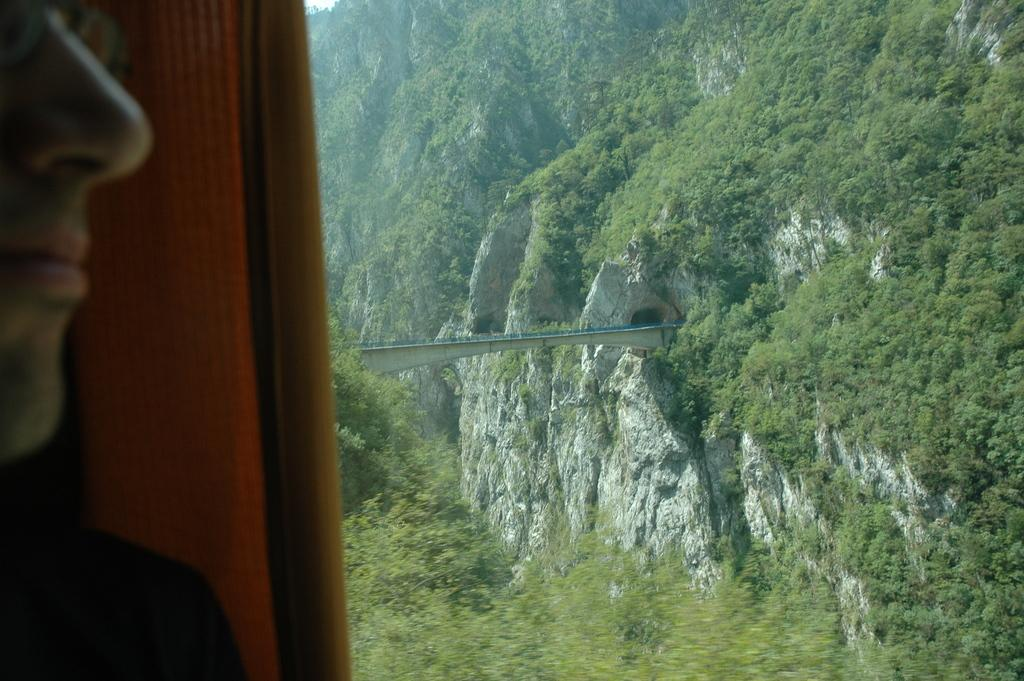What is the person in the image doing? The person is standing behind a wall. What can be seen in the distance in the image? There is a mountain and a bridge between the mountains in the background of the image. What type of vegetation is visible in the background? There are trees in the background of the image. Can you see any goldfish swimming in the river near the bridge? There is no river or goldfish present in the image; it features a mountain, a bridge, and trees in the background. 